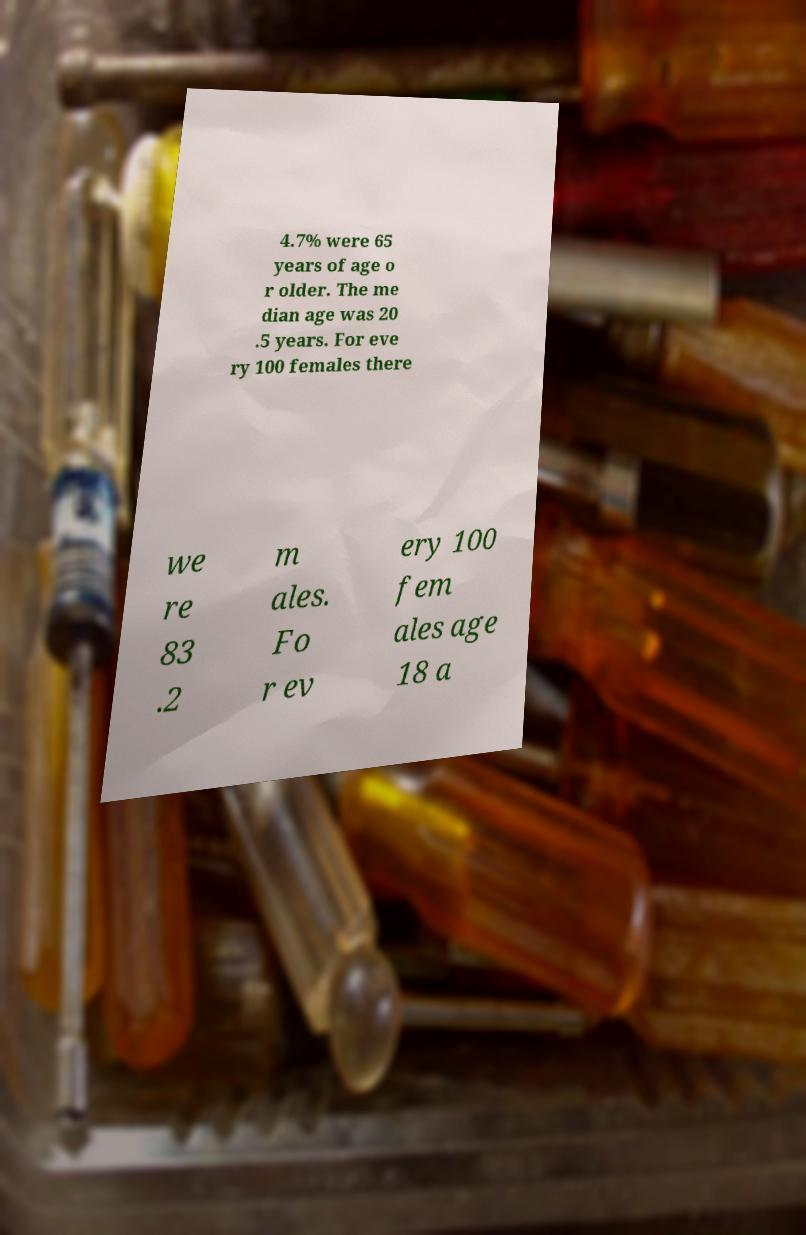Could you extract and type out the text from this image? 4.7% were 65 years of age o r older. The me dian age was 20 .5 years. For eve ry 100 females there we re 83 .2 m ales. Fo r ev ery 100 fem ales age 18 a 